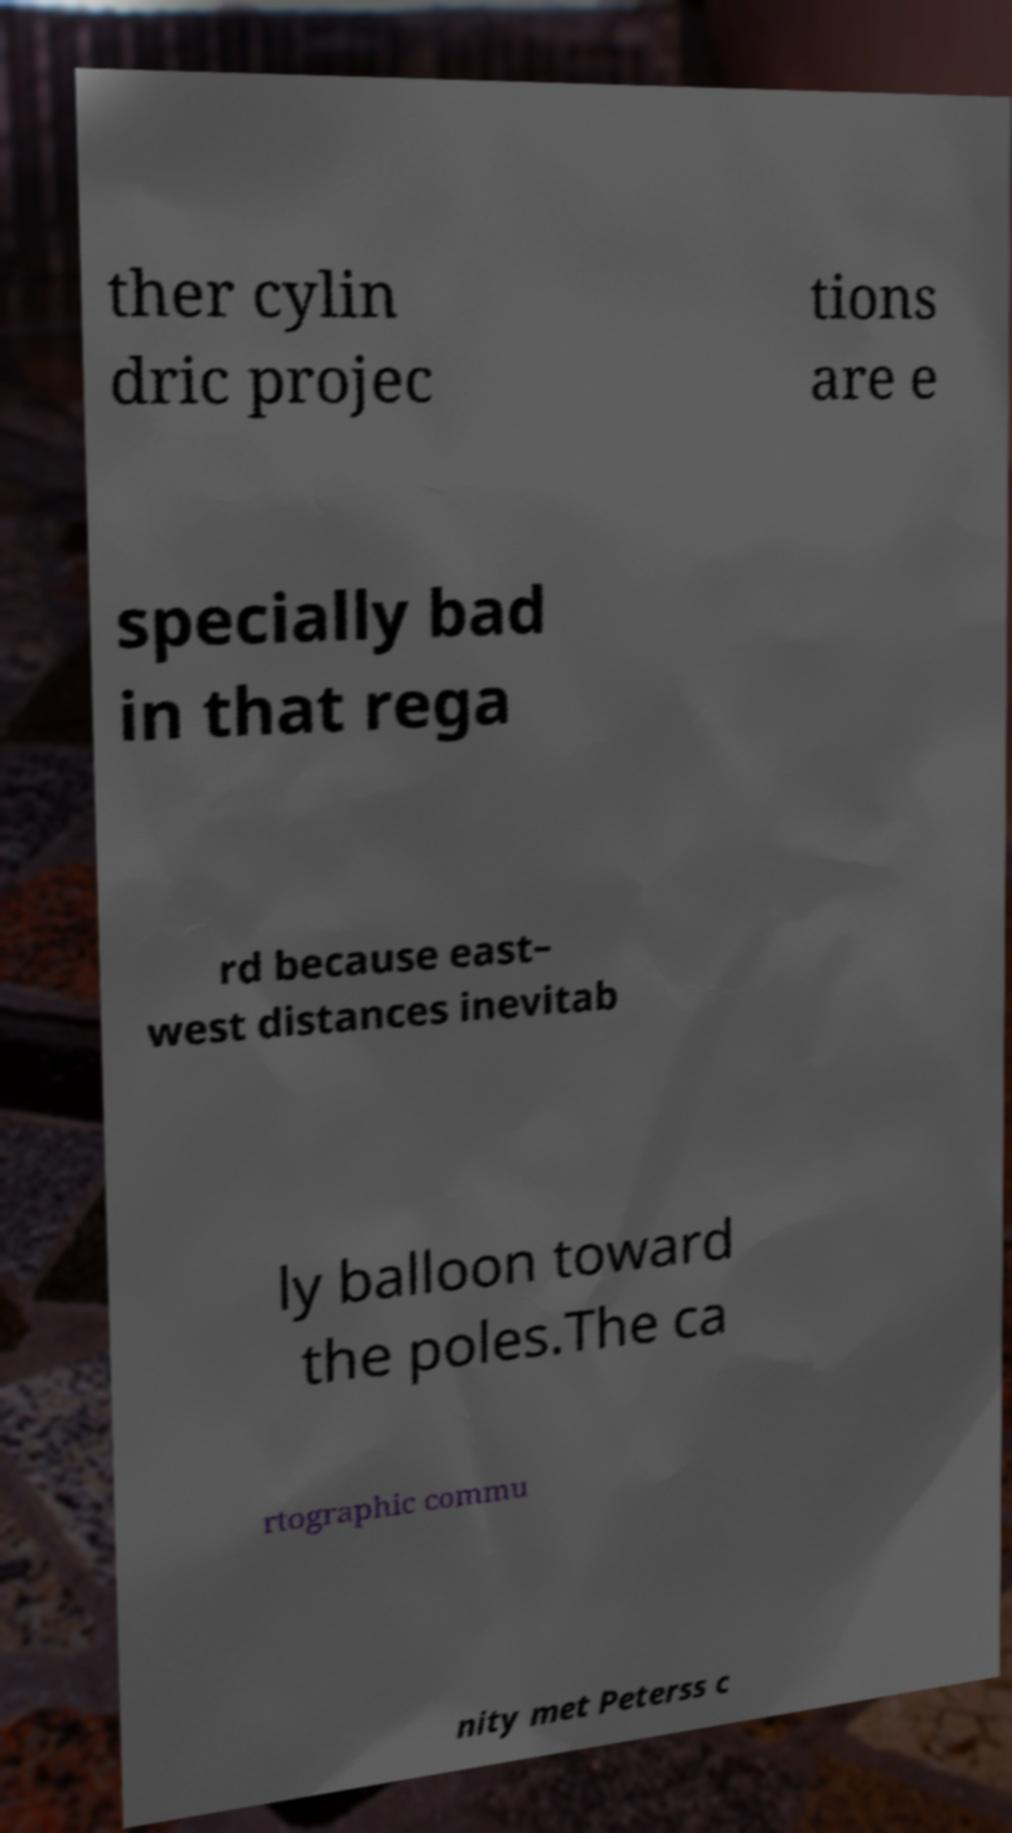Please identify and transcribe the text found in this image. ther cylin dric projec tions are e specially bad in that rega rd because east– west distances inevitab ly balloon toward the poles.The ca rtographic commu nity met Peterss c 